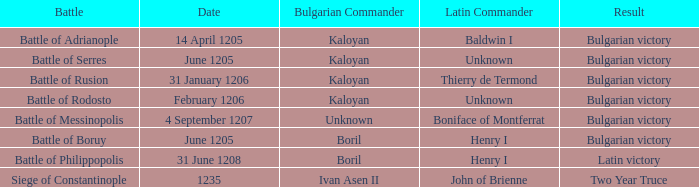On what Date was Henry I Latin Commander of the Battle of Boruy? June 1205. 